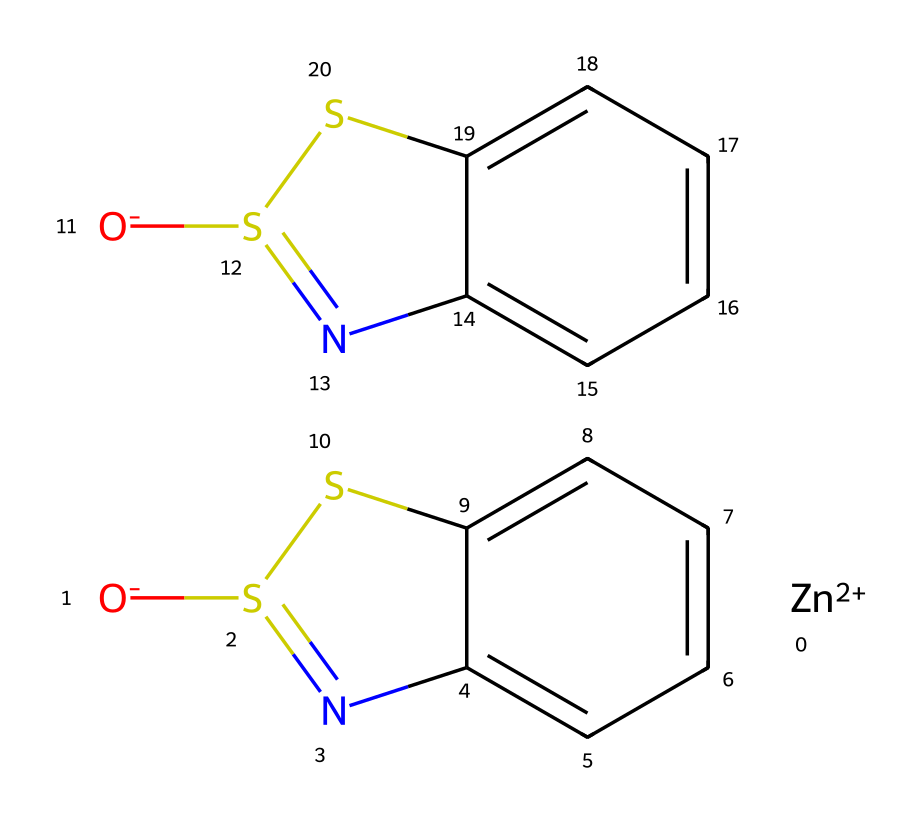What is the central metal in this compound? The compound contains the element zinc, which is indicated by the [Zn+2] in the SMILES representation, identifying it as the central metal in the structure.
Answer: zinc How many sulfur atoms are present in the structure? By examining the SMILES, we see there are two occurrences of the sulfur symbol (S), indicating two sulfur atoms present in the chemical structure.
Answer: 2 What class of chemicals does zinc pyrithione belong to? The presence of both zinc and a sulfur-containing heterocycle indicates that this compound is classified as an organometallic compound due to the bonding of metal (zinc) with organic components.
Answer: organometallic How many nitrogen atoms can be found in the structure? The chemical includes two nitrogen symbols (N), indicating there are two nitrogen atoms present within its structure.
Answer: 2 What type of bonding exists between zinc and the organic part of the molecule? The bonding between zinc and the organic portion is characterized as coordination bonding, where zinc forms a bond with the sulfur and nitrogen atoms of the heterocyclic structure.
Answer: coordination Which part of this chemical is responsible for its antifungal properties? The pyrithione portion containing sulfur and nitrogen atoms in a heterocyclic arrangement is what imparts antifungal properties due to its ability to disrupt fungal cell growth and function.
Answer: pyrithione 